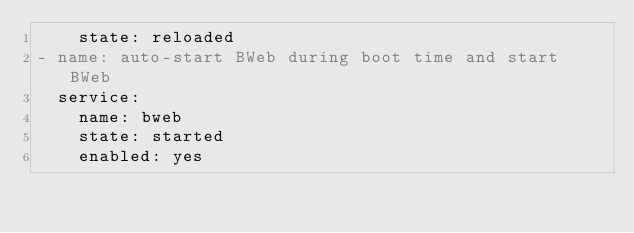Convert code to text. <code><loc_0><loc_0><loc_500><loc_500><_YAML_>    state: reloaded
- name: auto-start BWeb during boot time and start BWeb
  service:
    name: bweb
    state: started
    enabled: yes
</code> 